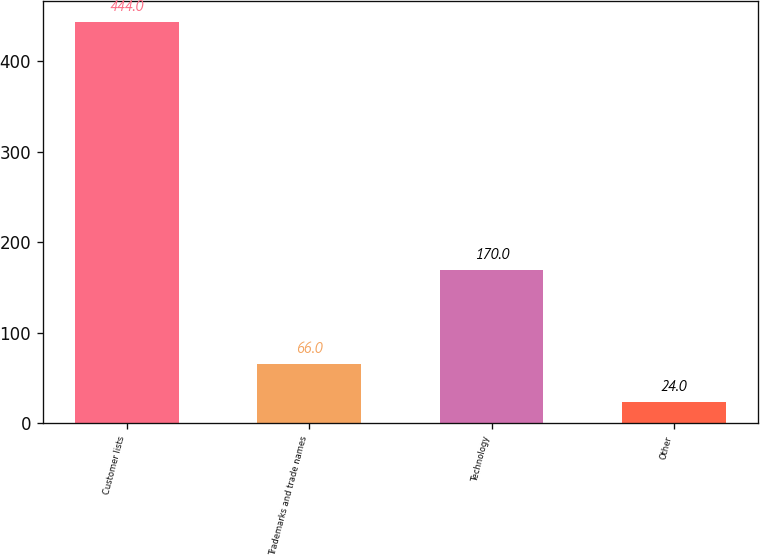Convert chart. <chart><loc_0><loc_0><loc_500><loc_500><bar_chart><fcel>Customer lists<fcel>Trademarks and trade names<fcel>Technology<fcel>Other<nl><fcel>444<fcel>66<fcel>170<fcel>24<nl></chart> 